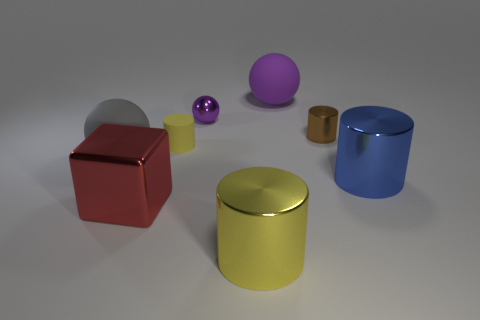There is another small object that is the same shape as the small yellow matte object; what material is it?
Make the answer very short. Metal. What shape is the matte object that is in front of the tiny yellow cylinder that is left of the big thing behind the tiny yellow object?
Keep it short and to the point. Sphere. Does the red metal cube have the same size as the yellow thing that is in front of the gray sphere?
Your response must be concise. Yes. Is there a cylinder that has the same size as the purple matte sphere?
Offer a very short reply. Yes. What number of other objects are the same material as the tiny purple object?
Offer a very short reply. 4. There is a big thing that is in front of the gray thing and left of the tiny matte object; what color is it?
Your answer should be compact. Red. Does the yellow thing that is on the right side of the tiny ball have the same material as the tiny cylinder that is behind the small rubber thing?
Make the answer very short. Yes. There is a rubber ball that is on the left side of the yellow metal thing; is it the same size as the blue shiny cylinder?
Offer a terse response. Yes. There is a small matte object; is it the same color as the tiny shiny object on the left side of the small brown thing?
Give a very brief answer. No. There is a big object that is the same color as the small ball; what is its shape?
Offer a very short reply. Sphere. 